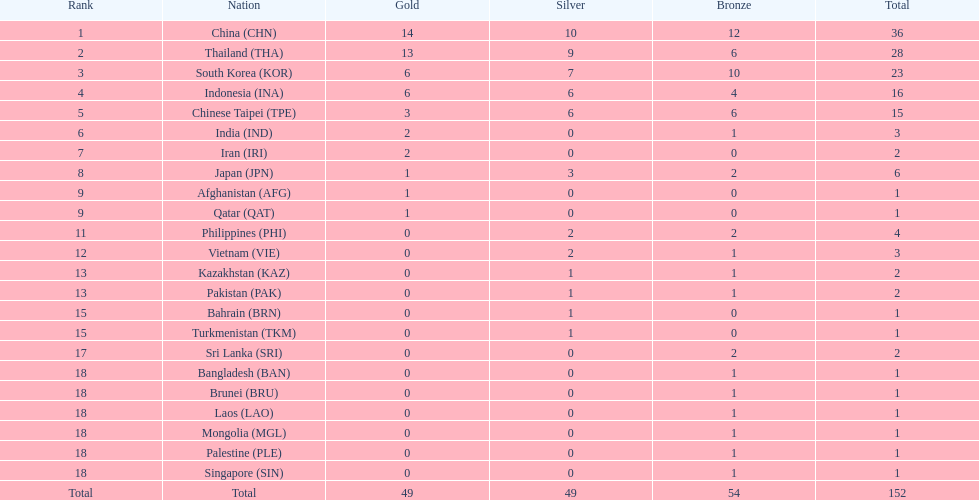How many countries received a medal in gold, silver, and bronze categories? 6. 